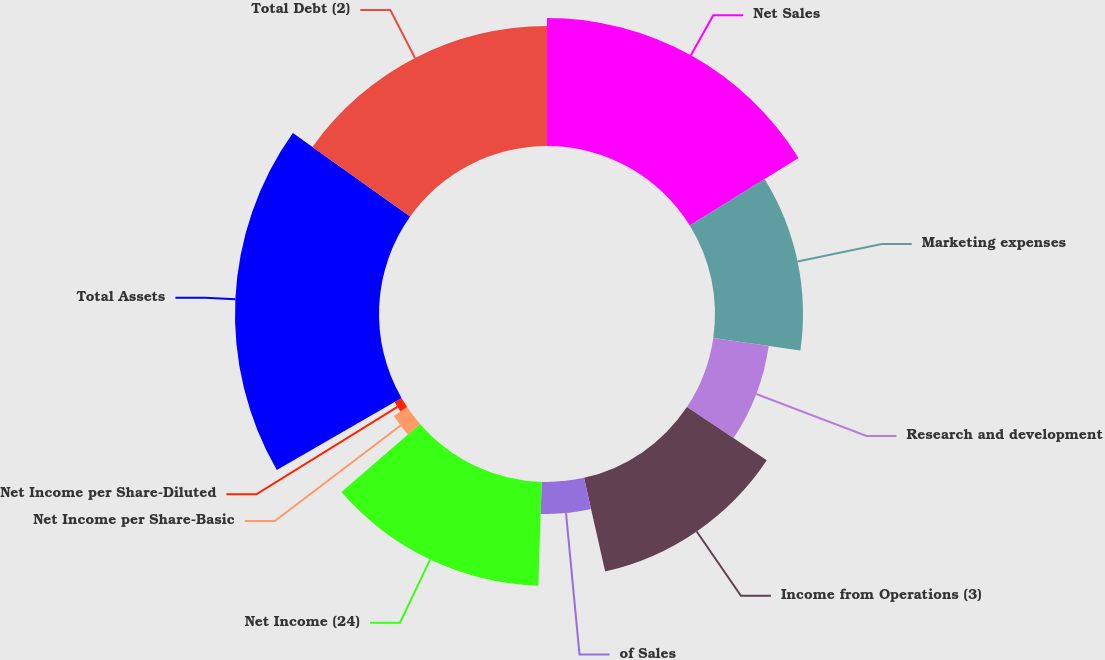<chart> <loc_0><loc_0><loc_500><loc_500><pie_chart><fcel>Net Sales<fcel>Marketing expenses<fcel>Research and development<fcel>Income from Operations (3)<fcel>of Sales<fcel>Net Income (24)<fcel>Net Income per Share-Basic<fcel>Net Income per Share-Diluted<fcel>Total Assets<fcel>Total Debt (2)<nl><fcel>16.16%<fcel>11.11%<fcel>7.07%<fcel>12.12%<fcel>4.04%<fcel>13.13%<fcel>2.02%<fcel>1.01%<fcel>18.18%<fcel>15.15%<nl></chart> 